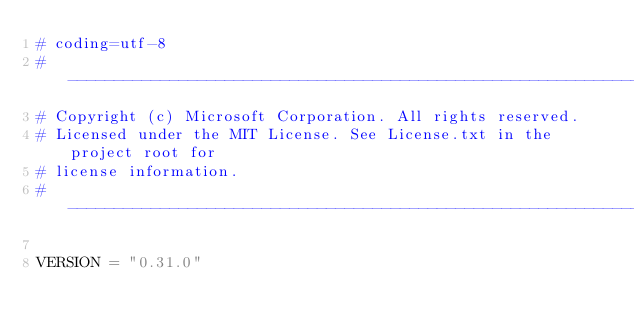<code> <loc_0><loc_0><loc_500><loc_500><_Python_># coding=utf-8
# --------------------------------------------------------------------------
# Copyright (c) Microsoft Corporation. All rights reserved.
# Licensed under the MIT License. See License.txt in the project root for
# license information.
# --------------------------------------------------------------------------

VERSION = "0.31.0"</code> 